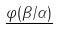Convert formula to latex. <formula><loc_0><loc_0><loc_500><loc_500>\underline { \varphi ( \beta / \alpha ) }</formula> 